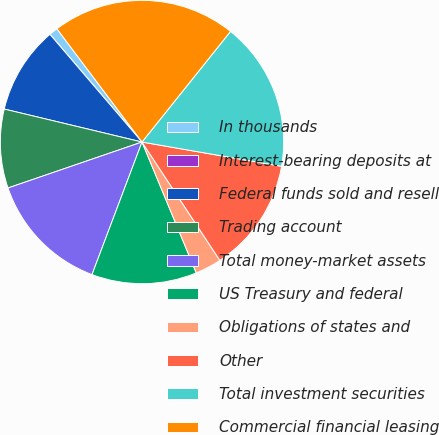Convert chart to OTSL. <chart><loc_0><loc_0><loc_500><loc_500><pie_chart><fcel>In thousands<fcel>Interest-bearing deposits at<fcel>Federal funds sold and resell<fcel>Trading account<fcel>Total money-market assets<fcel>US Treasury and federal<fcel>Obligations of states and<fcel>Other<fcel>Total investment securities<fcel>Commercial financial leasing<nl><fcel>1.0%<fcel>0.0%<fcel>10.0%<fcel>9.0%<fcel>14.0%<fcel>12.0%<fcel>3.0%<fcel>13.0%<fcel>17.0%<fcel>21.0%<nl></chart> 